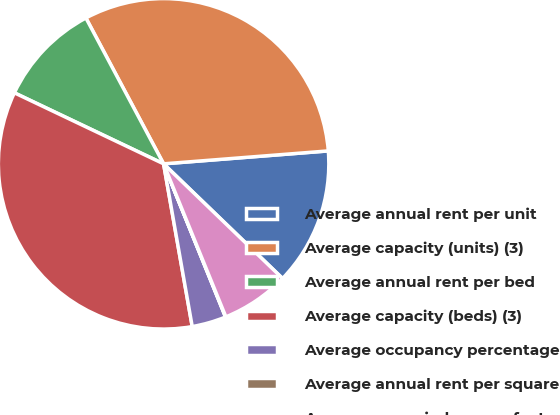Convert chart to OTSL. <chart><loc_0><loc_0><loc_500><loc_500><pie_chart><fcel>Average annual rent per unit<fcel>Average capacity (units) (3)<fcel>Average annual rent per bed<fcel>Average capacity (beds) (3)<fcel>Average occupancy percentage<fcel>Average annual rent per square<fcel>Average occupied square feet<nl><fcel>13.45%<fcel>31.54%<fcel>10.14%<fcel>34.84%<fcel>3.34%<fcel>0.04%<fcel>6.64%<nl></chart> 